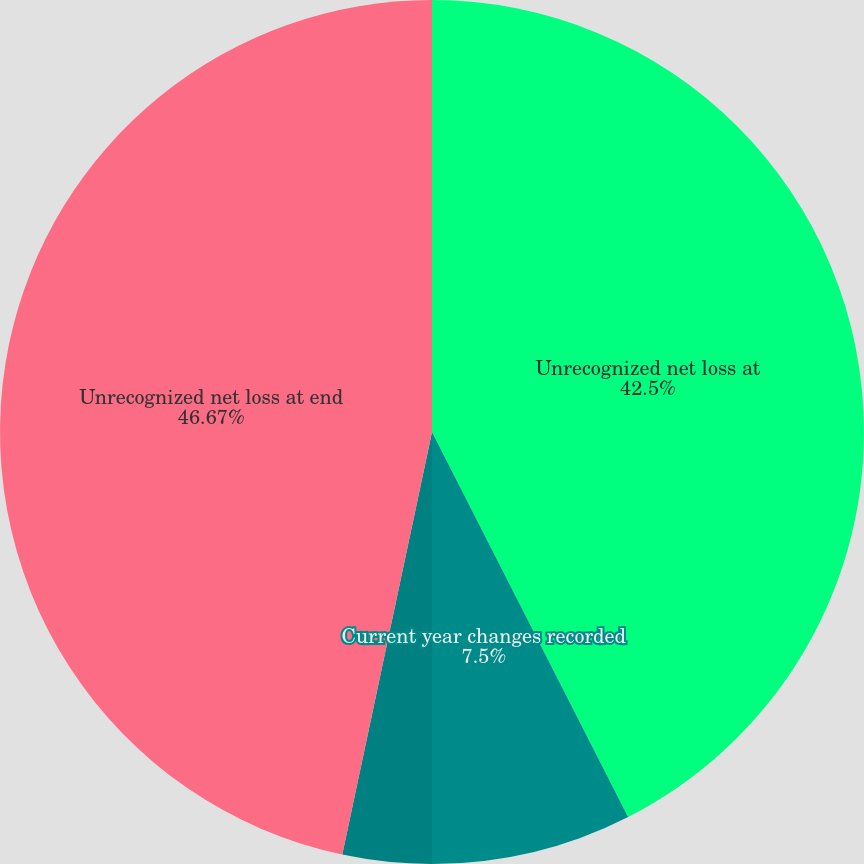Convert chart. <chart><loc_0><loc_0><loc_500><loc_500><pie_chart><fcel>Unrecognized net loss at<fcel>Current year changes recorded<fcel>Amortization reclassified to<fcel>Unrecognized net loss at end<nl><fcel>42.5%<fcel>7.5%<fcel>3.33%<fcel>46.67%<nl></chart> 